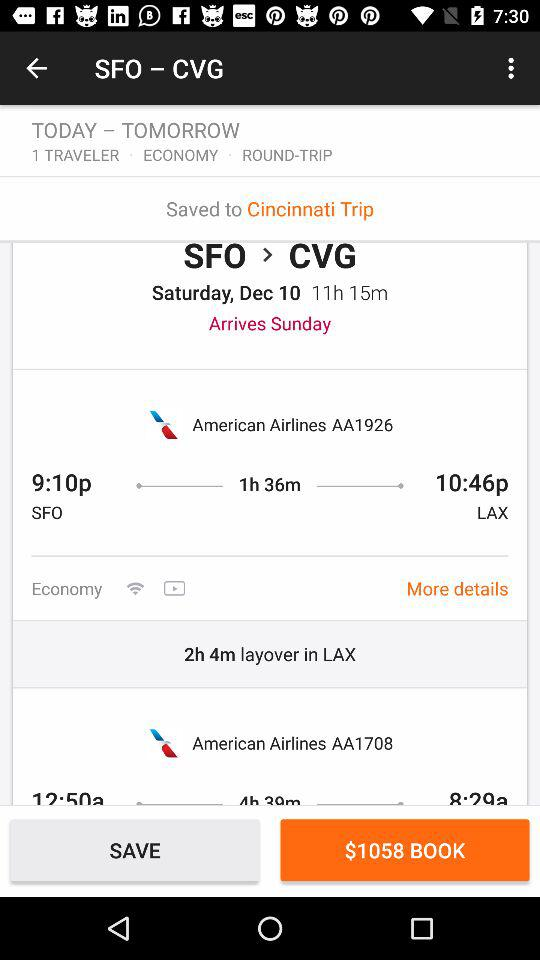How many hours is the layover in LAX?
Answer the question using a single word or phrase. 2h 4m 